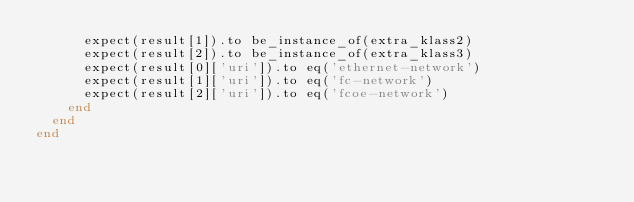Convert code to text. <code><loc_0><loc_0><loc_500><loc_500><_Ruby_>      expect(result[1]).to be_instance_of(extra_klass2)
      expect(result[2]).to be_instance_of(extra_klass3)
      expect(result[0]['uri']).to eq('ethernet-network')
      expect(result[1]['uri']).to eq('fc-network')
      expect(result[2]['uri']).to eq('fcoe-network')
    end
  end
end
</code> 